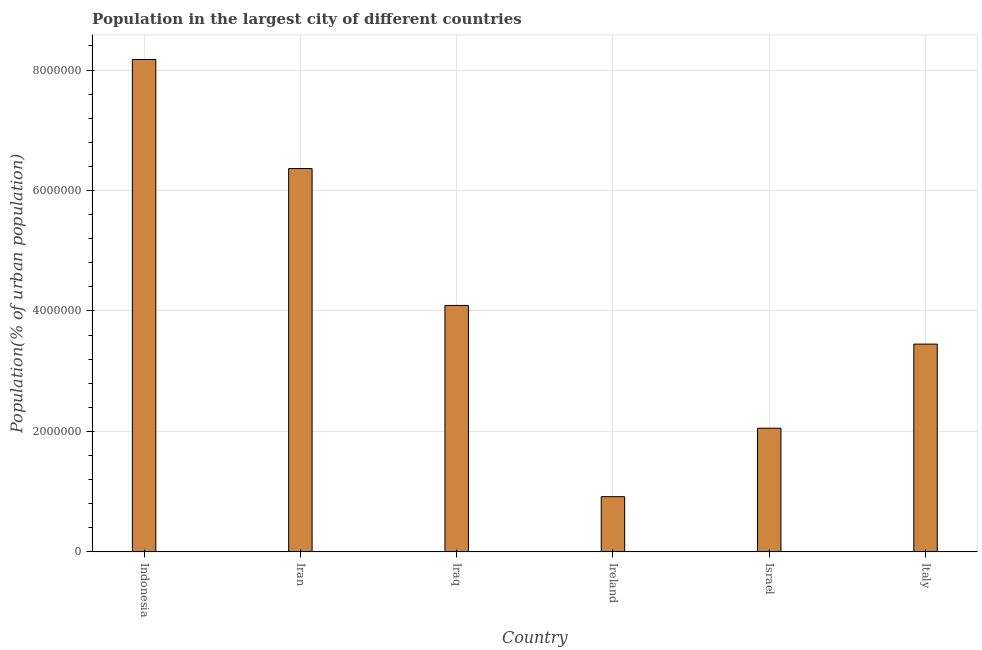Does the graph contain any zero values?
Make the answer very short. No. Does the graph contain grids?
Your response must be concise. Yes. What is the title of the graph?
Your response must be concise. Population in the largest city of different countries. What is the label or title of the X-axis?
Your answer should be very brief. Country. What is the label or title of the Y-axis?
Offer a terse response. Population(% of urban population). What is the population in largest city in Indonesia?
Your answer should be compact. 8.18e+06. Across all countries, what is the maximum population in largest city?
Ensure brevity in your answer.  8.18e+06. Across all countries, what is the minimum population in largest city?
Provide a succinct answer. 9.16e+05. In which country was the population in largest city maximum?
Offer a very short reply. Indonesia. In which country was the population in largest city minimum?
Your answer should be compact. Ireland. What is the sum of the population in largest city?
Your answer should be compact. 2.51e+07. What is the difference between the population in largest city in Iraq and Israel?
Make the answer very short. 2.04e+06. What is the average population in largest city per country?
Your answer should be very brief. 4.18e+06. What is the median population in largest city?
Provide a succinct answer. 3.77e+06. What is the ratio of the population in largest city in Indonesia to that in Italy?
Keep it short and to the point. 2.37. Is the difference between the population in largest city in Iran and Iraq greater than the difference between any two countries?
Offer a very short reply. No. What is the difference between the highest and the second highest population in largest city?
Offer a very short reply. 1.81e+06. What is the difference between the highest and the lowest population in largest city?
Provide a short and direct response. 7.26e+06. Are the values on the major ticks of Y-axis written in scientific E-notation?
Offer a very short reply. No. What is the Population(% of urban population) of Indonesia?
Provide a succinct answer. 8.18e+06. What is the Population(% of urban population) of Iran?
Make the answer very short. 6.36e+06. What is the Population(% of urban population) in Iraq?
Offer a terse response. 4.09e+06. What is the Population(% of urban population) in Ireland?
Give a very brief answer. 9.16e+05. What is the Population(% of urban population) in Israel?
Your answer should be compact. 2.05e+06. What is the Population(% of urban population) of Italy?
Provide a short and direct response. 3.45e+06. What is the difference between the Population(% of urban population) in Indonesia and Iran?
Offer a very short reply. 1.81e+06. What is the difference between the Population(% of urban population) in Indonesia and Iraq?
Provide a short and direct response. 4.08e+06. What is the difference between the Population(% of urban population) in Indonesia and Ireland?
Provide a succinct answer. 7.26e+06. What is the difference between the Population(% of urban population) in Indonesia and Israel?
Your answer should be compact. 6.12e+06. What is the difference between the Population(% of urban population) in Indonesia and Italy?
Make the answer very short. 4.73e+06. What is the difference between the Population(% of urban population) in Iran and Iraq?
Your response must be concise. 2.27e+06. What is the difference between the Population(% of urban population) in Iran and Ireland?
Provide a succinct answer. 5.45e+06. What is the difference between the Population(% of urban population) in Iran and Israel?
Ensure brevity in your answer.  4.31e+06. What is the difference between the Population(% of urban population) in Iran and Italy?
Your response must be concise. 2.92e+06. What is the difference between the Population(% of urban population) in Iraq and Ireland?
Provide a succinct answer. 3.18e+06. What is the difference between the Population(% of urban population) in Iraq and Israel?
Your answer should be compact. 2.04e+06. What is the difference between the Population(% of urban population) in Iraq and Italy?
Provide a short and direct response. 6.42e+05. What is the difference between the Population(% of urban population) in Ireland and Israel?
Offer a terse response. -1.14e+06. What is the difference between the Population(% of urban population) in Ireland and Italy?
Ensure brevity in your answer.  -2.53e+06. What is the difference between the Population(% of urban population) in Israel and Italy?
Offer a very short reply. -1.40e+06. What is the ratio of the Population(% of urban population) in Indonesia to that in Iran?
Offer a very short reply. 1.28. What is the ratio of the Population(% of urban population) in Indonesia to that in Iraq?
Offer a very short reply. 2. What is the ratio of the Population(% of urban population) in Indonesia to that in Ireland?
Offer a very short reply. 8.92. What is the ratio of the Population(% of urban population) in Indonesia to that in Israel?
Ensure brevity in your answer.  3.98. What is the ratio of the Population(% of urban population) in Indonesia to that in Italy?
Provide a succinct answer. 2.37. What is the ratio of the Population(% of urban population) in Iran to that in Iraq?
Offer a very short reply. 1.56. What is the ratio of the Population(% of urban population) in Iran to that in Ireland?
Offer a terse response. 6.95. What is the ratio of the Population(% of urban population) in Iran to that in Israel?
Keep it short and to the point. 3.1. What is the ratio of the Population(% of urban population) in Iran to that in Italy?
Provide a succinct answer. 1.84. What is the ratio of the Population(% of urban population) in Iraq to that in Ireland?
Keep it short and to the point. 4.46. What is the ratio of the Population(% of urban population) in Iraq to that in Israel?
Ensure brevity in your answer.  1.99. What is the ratio of the Population(% of urban population) in Iraq to that in Italy?
Your answer should be compact. 1.19. What is the ratio of the Population(% of urban population) in Ireland to that in Israel?
Provide a short and direct response. 0.45. What is the ratio of the Population(% of urban population) in Ireland to that in Italy?
Offer a terse response. 0.27. What is the ratio of the Population(% of urban population) in Israel to that in Italy?
Keep it short and to the point. 0.59. 